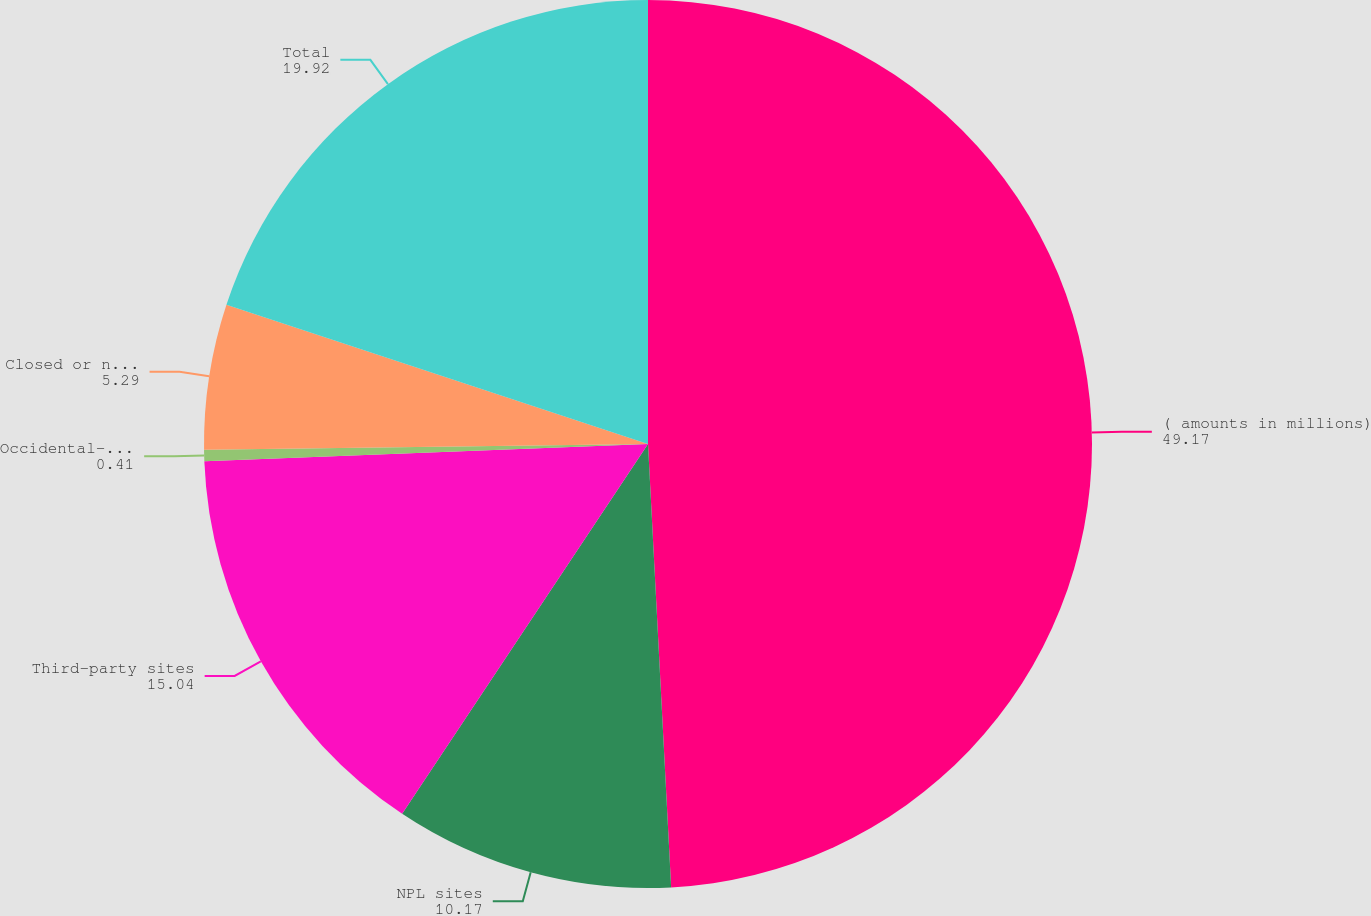<chart> <loc_0><loc_0><loc_500><loc_500><pie_chart><fcel>( amounts in millions)<fcel>NPL sites<fcel>Third-party sites<fcel>Occidental-operated sites<fcel>Closed or non-operated<fcel>Total<nl><fcel>49.17%<fcel>10.17%<fcel>15.04%<fcel>0.41%<fcel>5.29%<fcel>19.92%<nl></chart> 